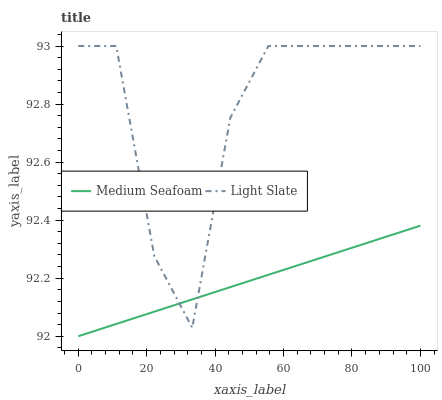Does Medium Seafoam have the maximum area under the curve?
Answer yes or no. No. Is Medium Seafoam the roughest?
Answer yes or no. No. Does Medium Seafoam have the highest value?
Answer yes or no. No. 